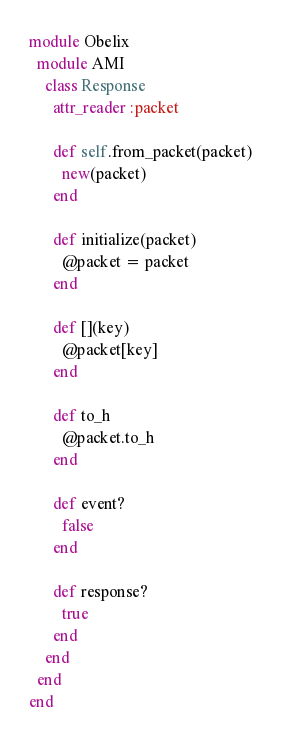<code> <loc_0><loc_0><loc_500><loc_500><_Ruby_>module Obelix
  module AMI
    class Response
      attr_reader :packet

      def self.from_packet(packet)
        new(packet)
      end

      def initialize(packet)
        @packet = packet
      end

      def [](key)
        @packet[key]
      end

      def to_h
        @packet.to_h
      end

      def event?
        false
      end

      def response?
        true
      end
    end
  end
end
</code> 